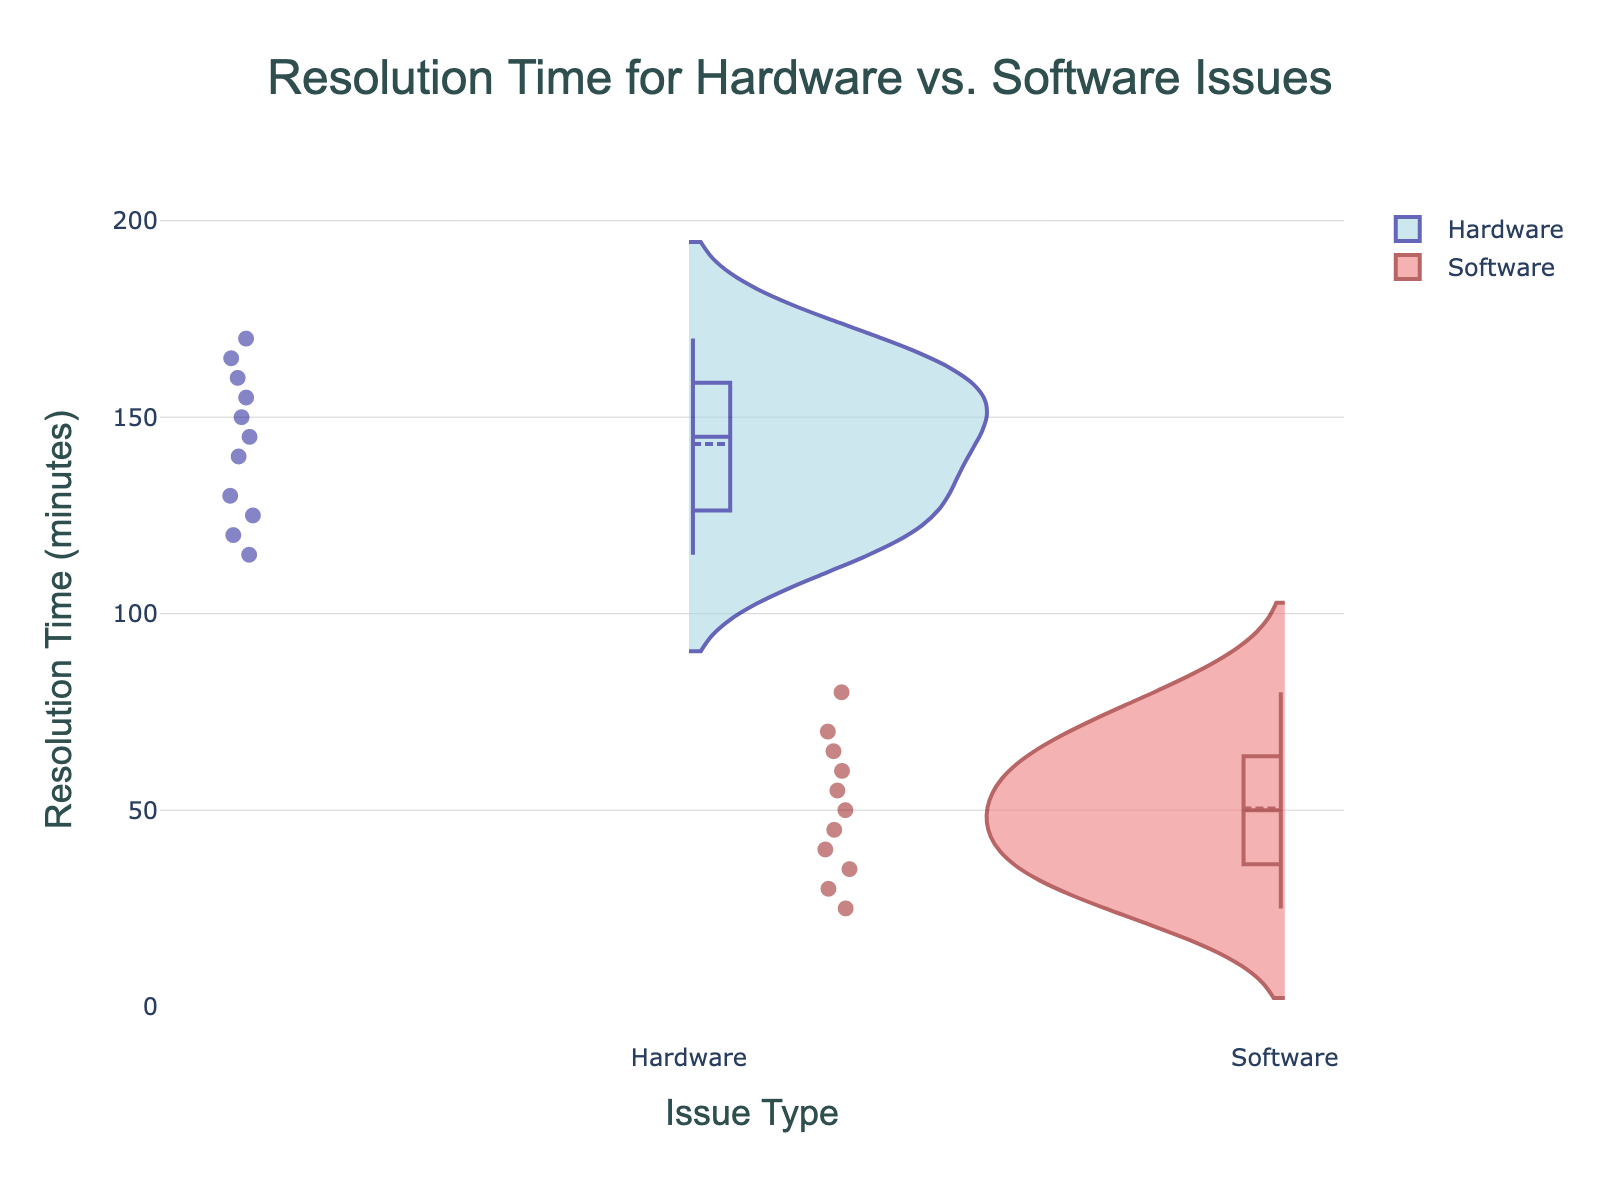what is the title of the figure? The title is often found at the top of the chart, providing a summary of what the chart represents. In this case, it's clearly labeled.
Answer: Resolution Time for Hardware vs. Software Issues what are the axis labels in the figure? The axis labels help identify what each axis represents. Here, the x-axis represents "Issue Type" and the y-axis represents "Resolution Time (minutes)".
Answer: Issue Type, Resolution Time (minutes) How many distinct issue types are displayed in the figure? Issue types are categorized on the x-axis. There are two distinct issue types indicated by the violins.
Answer: 2 What color represents Hardware issues in the plot? The color for Hardware issues can be identified by looking at the violin plot's coloring.
Answer: Light blue What color represents Software issues in the plot? The color for Software issues is shown by the violin plot coloring for negative side.
Answer: Light coral What is the mean resolution time for Hardware issues? The mean is represented by a horizontal line across the violin plot. For Hardware, this line is around the 145 mark.
Answer: Approximately 145 minutes Which issue type has the shorter median resolution time? Compare the horizontal lines indicating the median in each violin plot, which are visible within the boxes. Software’s median is below 55, and Hardware’s is above 140.
Answer: Software How many data points are displayed for Hardware issues? Each point within the violin, scattered around, represents a data point. Counting the points in the Hardware side gives the answer.
Answer: 11 How many data points are displayed for Software issues? Similar to the previous question, counting the points on the Software side of the plot gives the total number.
Answer: 11 What is the range of resolution times for Software issues? The plot extends from the minimum to the maximum points for Software issues, which range between 25 to 80 minutes.
Answer: 25 to 80 minutes 